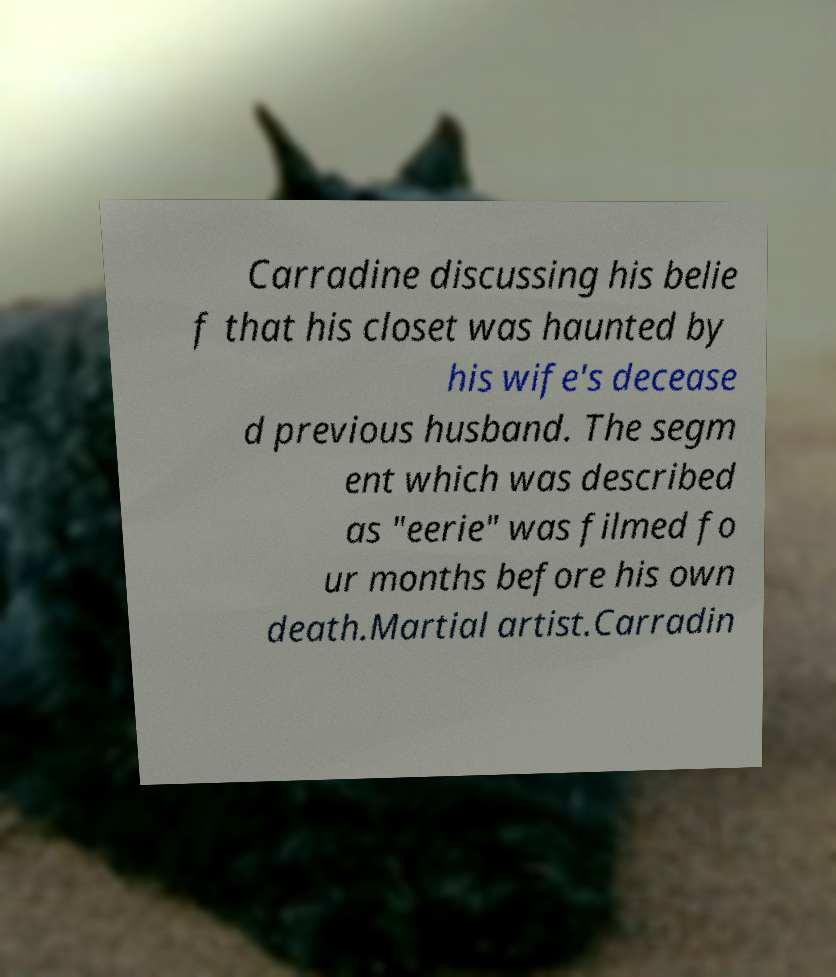For documentation purposes, I need the text within this image transcribed. Could you provide that? Carradine discussing his belie f that his closet was haunted by his wife's decease d previous husband. The segm ent which was described as "eerie" was filmed fo ur months before his own death.Martial artist.Carradin 